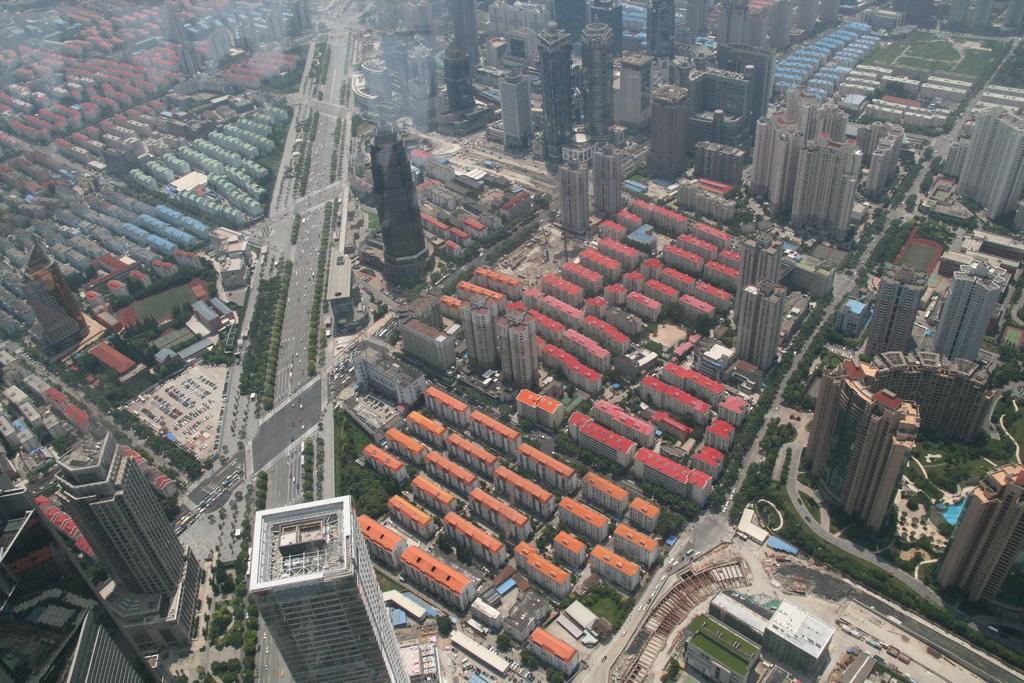Can you describe this image briefly? in this picture there are buildings,trees and roads. 